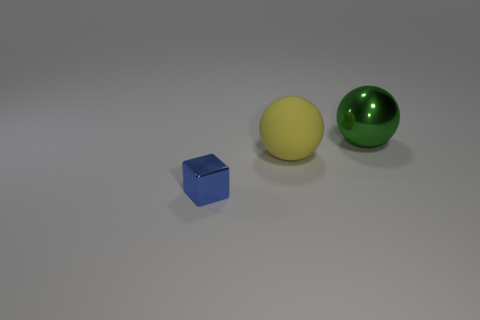Is the color of the shiny cube the same as the big shiny sphere?
Offer a very short reply. No. How many metallic objects are the same shape as the big matte thing?
Your answer should be very brief. 1. There is a sphere that is made of the same material as the tiny blue block; what is its size?
Provide a succinct answer. Large. How many green cubes have the same size as the rubber thing?
Make the answer very short. 0. There is a object that is both in front of the green sphere and behind the small block; how big is it?
Provide a short and direct response. Large. What number of yellow matte things are behind the sphere that is in front of the ball that is right of the matte ball?
Your response must be concise. 0. Is there a metal ball of the same color as the large rubber object?
Offer a terse response. No. There is a rubber object that is the same size as the green metallic object; what is its color?
Provide a succinct answer. Yellow. What shape is the metal thing that is behind the shiny thing that is on the left side of the large object behind the yellow rubber sphere?
Provide a succinct answer. Sphere. How many large shiny things are on the right side of the shiny object right of the tiny cube?
Your answer should be very brief. 0. 